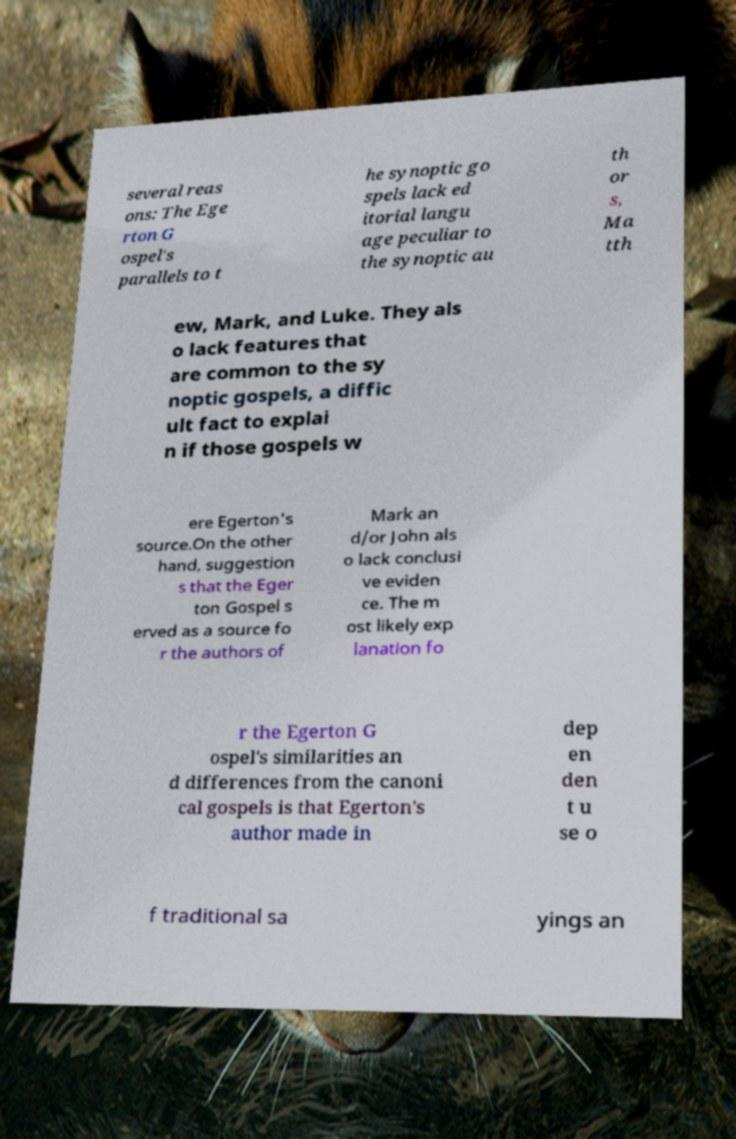Please read and relay the text visible in this image. What does it say? several reas ons: The Ege rton G ospel's parallels to t he synoptic go spels lack ed itorial langu age peculiar to the synoptic au th or s, Ma tth ew, Mark, and Luke. They als o lack features that are common to the sy noptic gospels, a diffic ult fact to explai n if those gospels w ere Egerton's source.On the other hand, suggestion s that the Eger ton Gospel s erved as a source fo r the authors of Mark an d/or John als o lack conclusi ve eviden ce. The m ost likely exp lanation fo r the Egerton G ospel's similarities an d differences from the canoni cal gospels is that Egerton's author made in dep en den t u se o f traditional sa yings an 